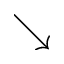<formula> <loc_0><loc_0><loc_500><loc_500>\searrow</formula> 